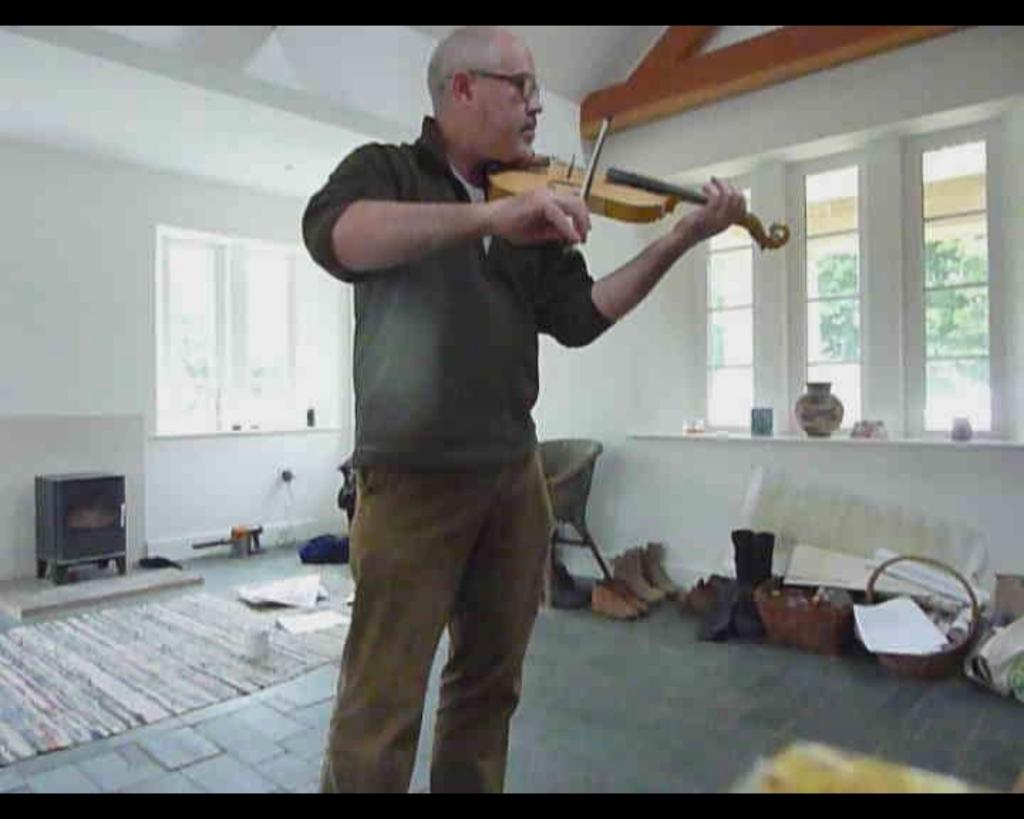Who is present in the image? There is a man in the image. What is the man holding in his hand? The man is holding a violin in his hand. What color are the walls in the background of the image? The walls in the background are white. What type of sponge is the man using to clean the violin in the image? There is no sponge present in the image, nor is the man cleaning the violin. 